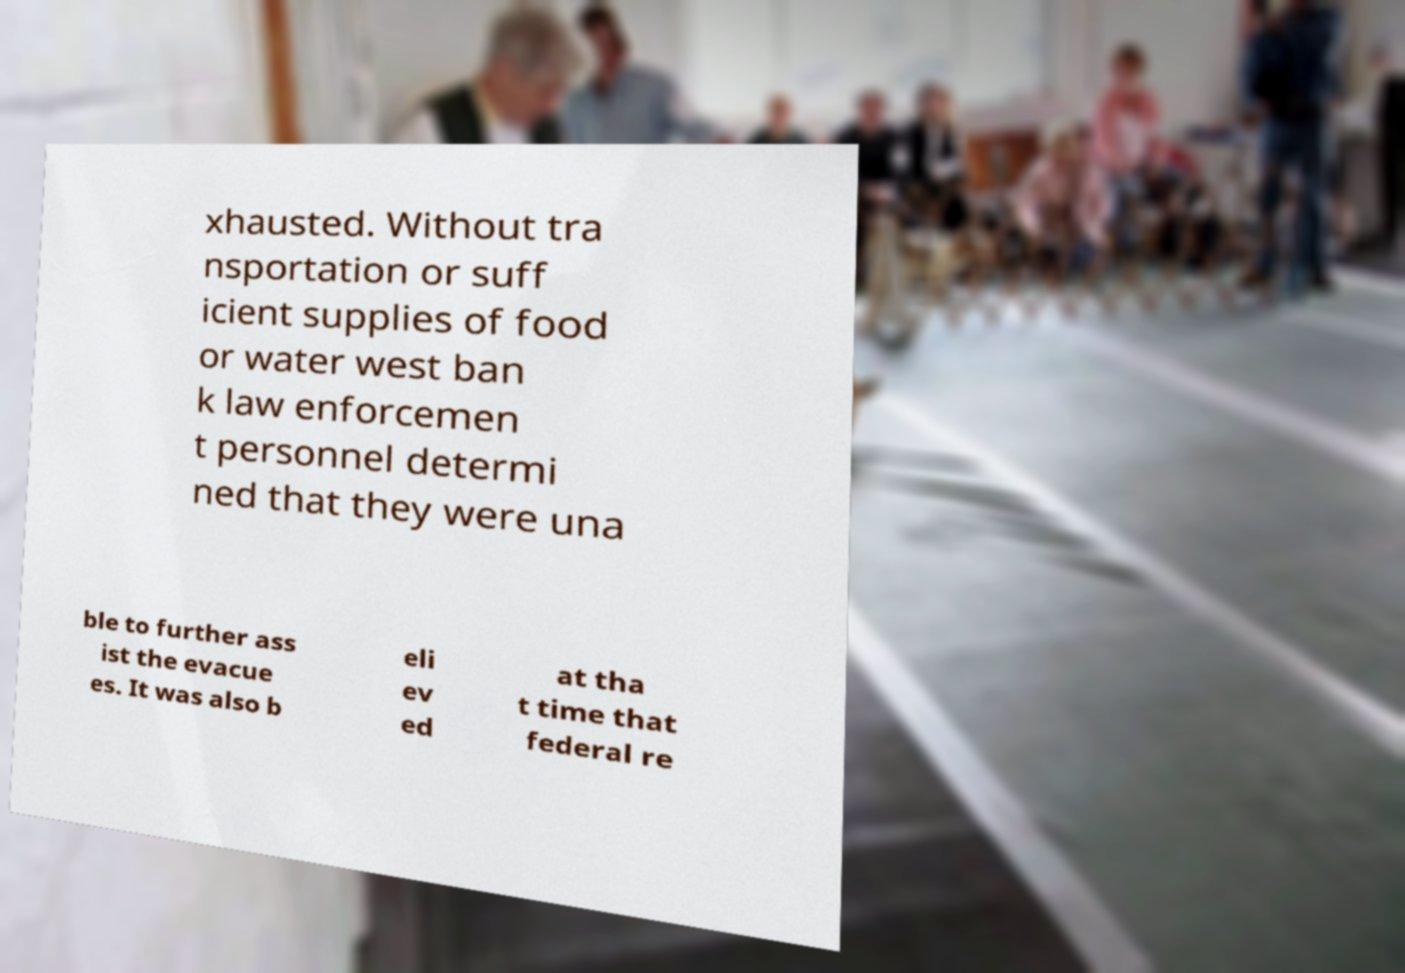What messages or text are displayed in this image? I need them in a readable, typed format. xhausted. Without tra nsportation or suff icient supplies of food or water west ban k law enforcemen t personnel determi ned that they were una ble to further ass ist the evacue es. It was also b eli ev ed at tha t time that federal re 